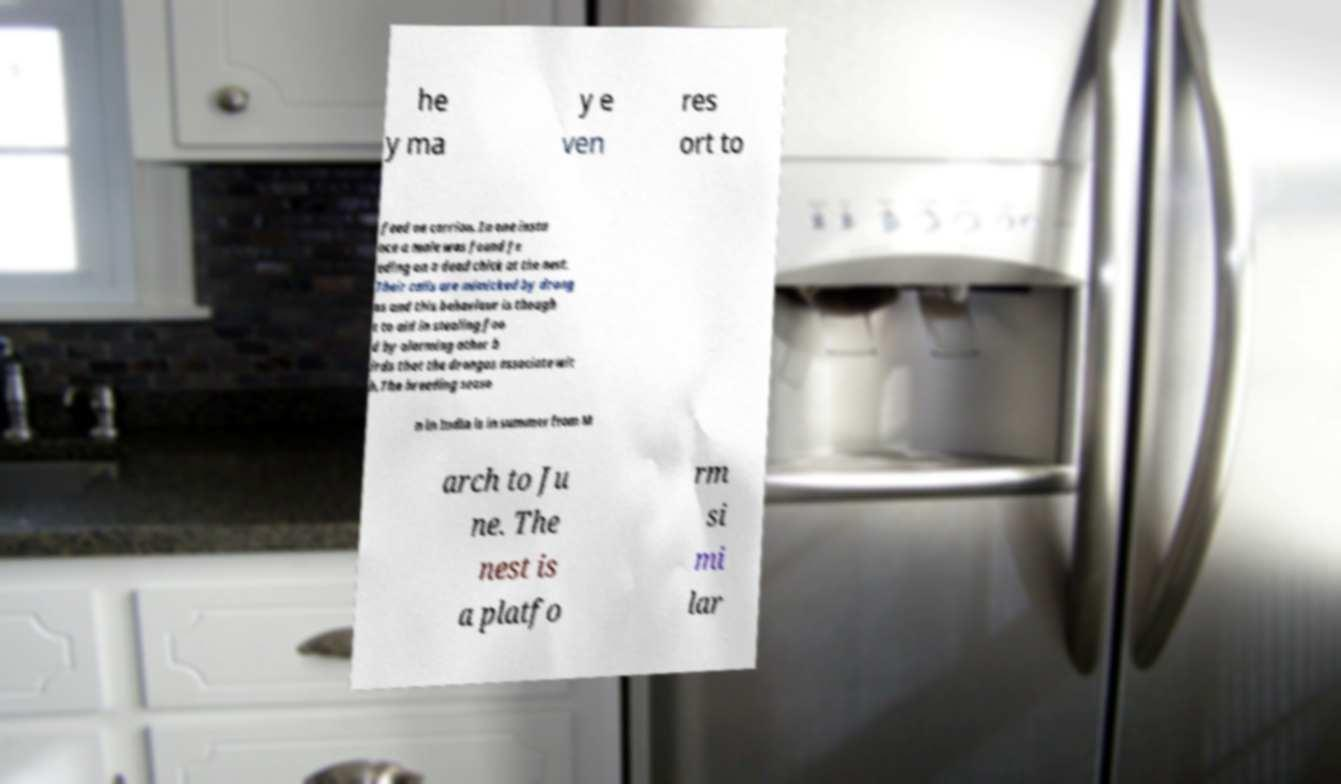Could you extract and type out the text from this image? he y ma y e ven res ort to feed on carrion. In one insta nce a male was found fe eding on a dead chick at the nest. Their calls are mimicked by drong os and this behaviour is though t to aid in stealing foo d by alarming other b irds that the drongos associate wit h.The breeding seaso n in India is in summer from M arch to Ju ne. The nest is a platfo rm si mi lar 